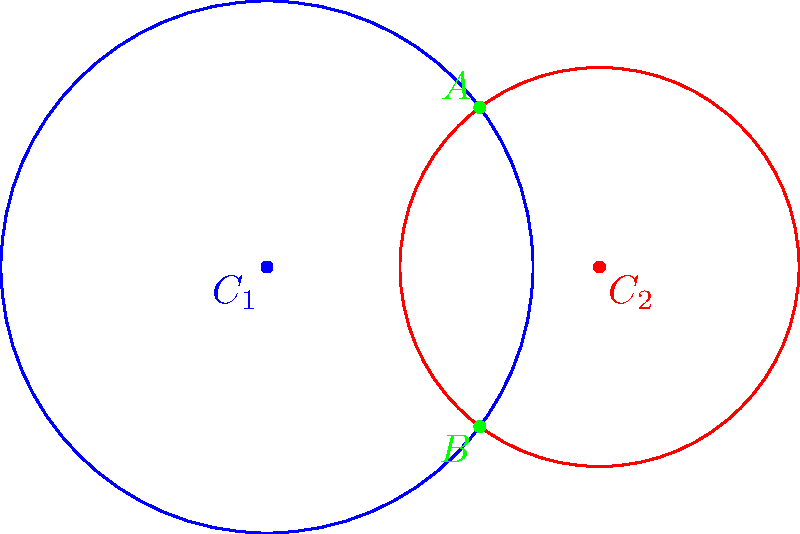In a study of cultural influence, two immigrant communities are represented by circles of influence. Circle $C_1$, centered at (0,0) with radius 4, represents the cultural reach of the first community. Circle $C_2$, centered at (5,0) with radius 3, represents the second community. The points where these circles intersect indicate areas of cultural overlap.

Find the y-coordinate of the upper intersection point (point A) of these two circles. Round your answer to two decimal places. Let's approach this step-by-step:

1) The equation of circle $C_1$ is: $x^2 + y^2 = 16$
2) The equation of circle $C_2$ is: $(x-5)^2 + y^2 = 9$

3) To find the intersection points, we need to solve these equations simultaneously:
   $x^2 + y^2 = 16$ ... (1)
   $(x-5)^2 + y^2 = 9$ ... (2)

4) Expanding equation (2):
   $x^2 - 10x + 25 + y^2 = 9$

5) Subtracting equation (1) from this expanded form of (2):
   $-10x + 25 = 9 - 16$
   $-10x = -32$
   $x = 3.2$

6) Substitute this x-value back into equation (1):
   $(3.2)^2 + y^2 = 16$
   $10.24 + y^2 = 16$
   $y^2 = 5.76$
   $y = \pm \sqrt{5.76} = \pm 2.4$

7) The y-coordinate of the upper intersection point (A) is the positive value: 2.4

Therefore, the y-coordinate of point A is approximately 2.40.
Answer: 2.40 